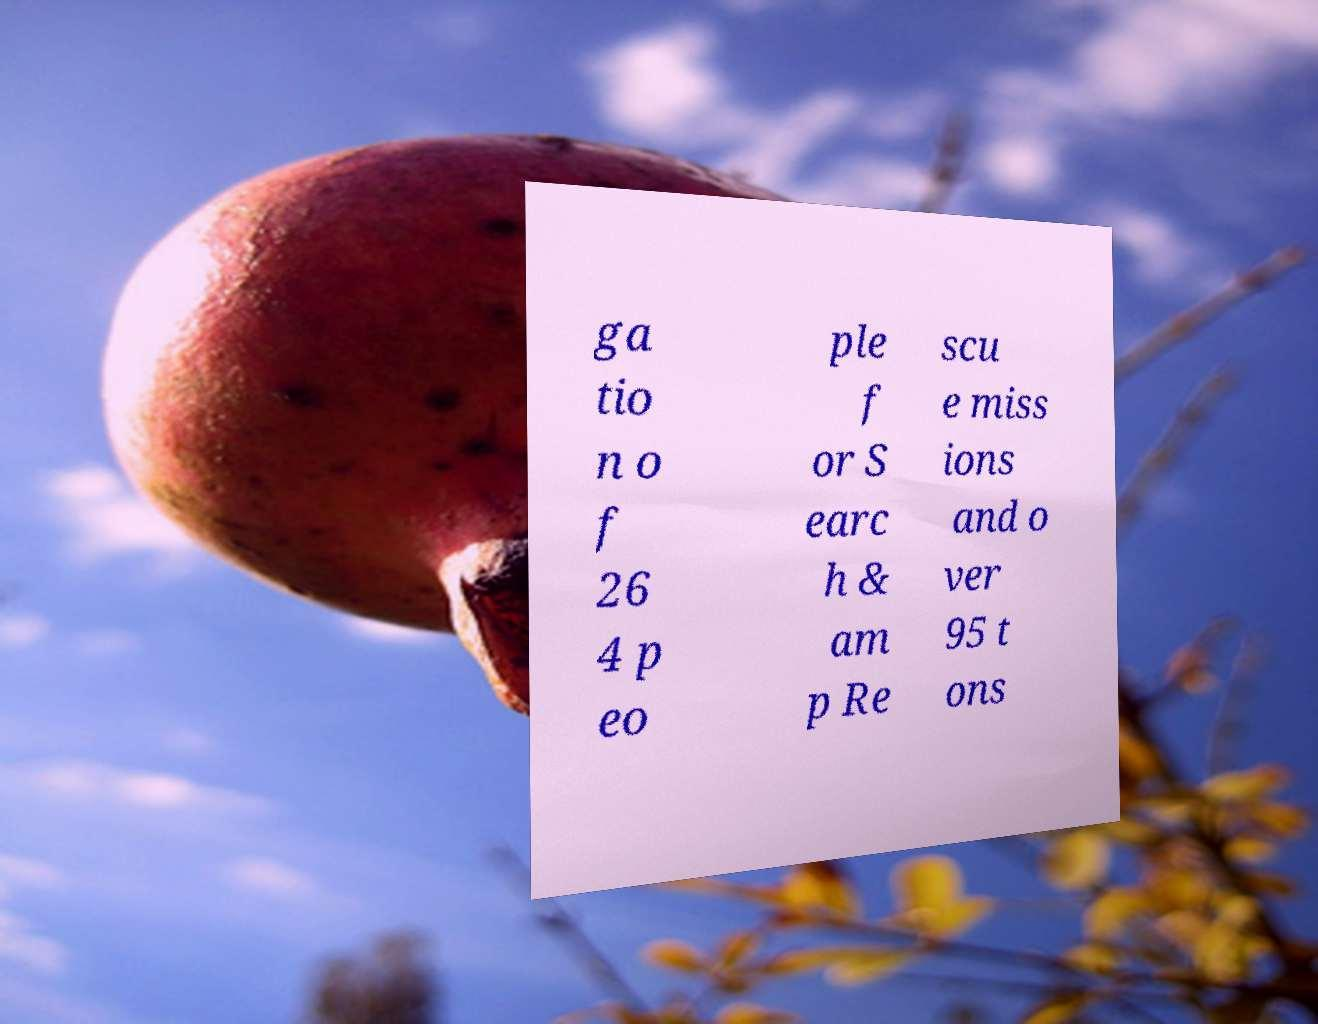Could you extract and type out the text from this image? ga tio n o f 26 4 p eo ple f or S earc h & am p Re scu e miss ions and o ver 95 t ons 